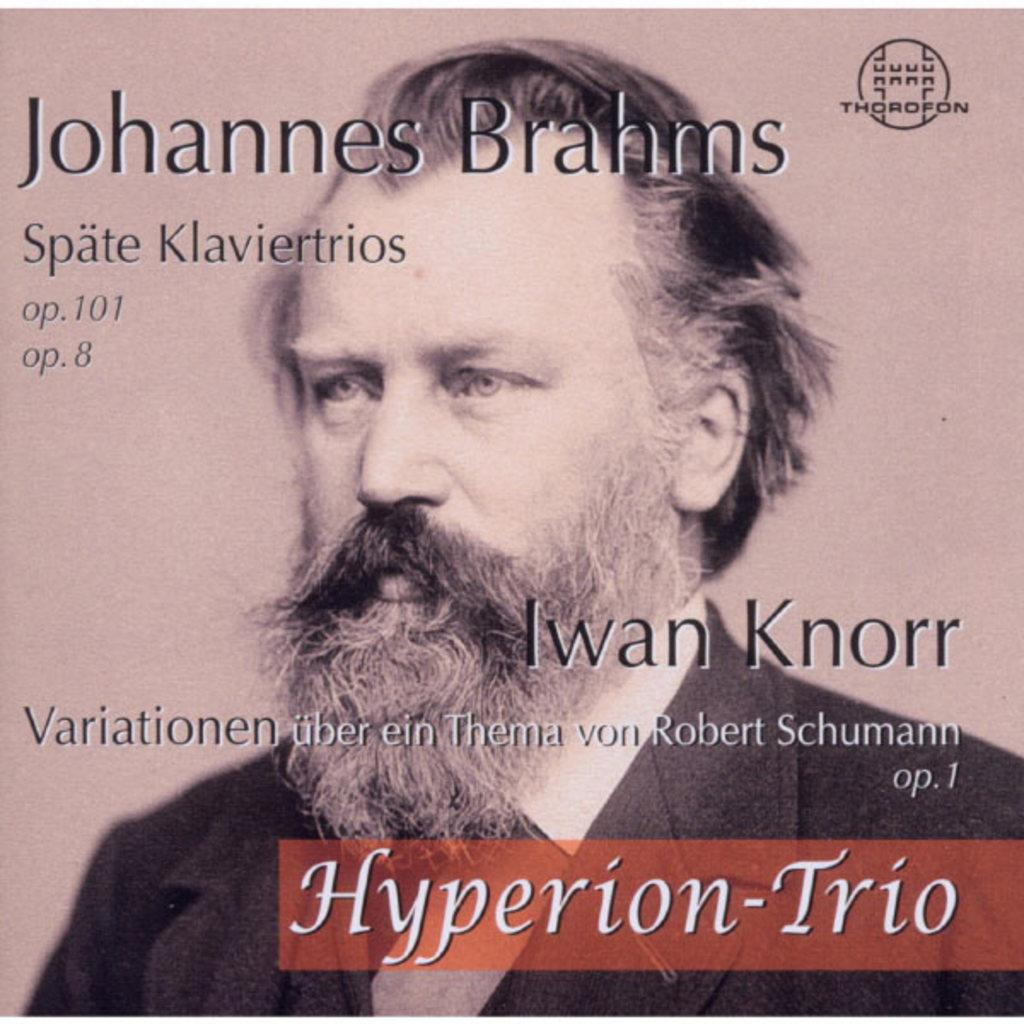Who is present in the image? There is a man in the image. What is the man wearing? The man is wearing a suit. What else can be seen in the image besides the man? There are words and numbers, as well as a logo in the image. How does the maid react to the earthquake in the image? There is no maid or earthquake present in the image. What type of sorting is being done with the numbers in the image? There is no sorting activity depicted in the image; it only contains words and numbers. 